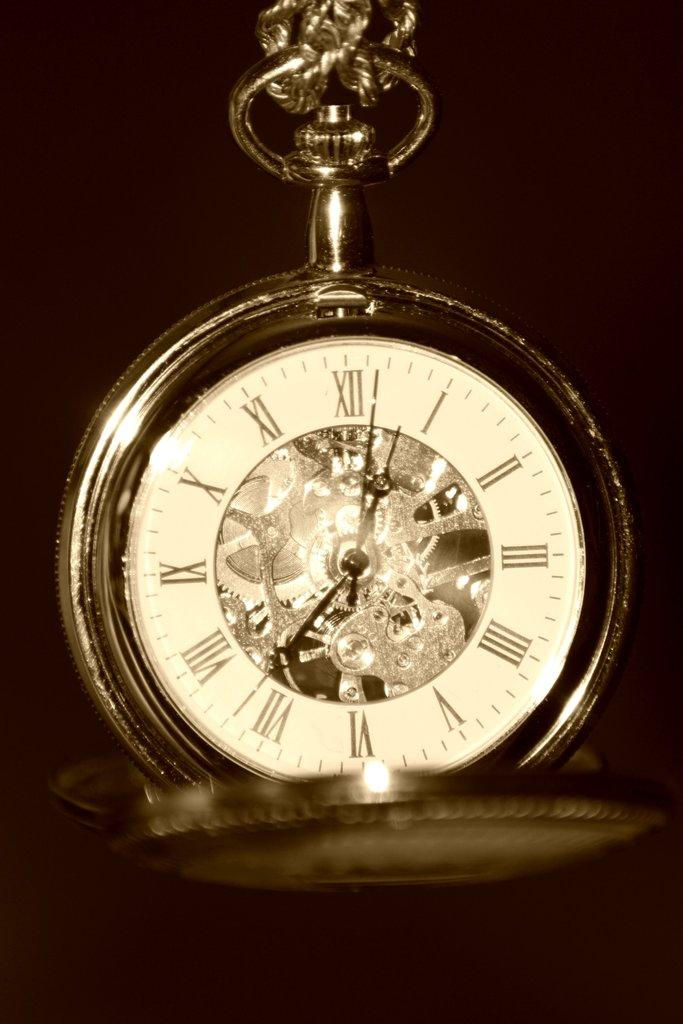<image>
Write a terse but informative summary of the picture. dark background and open pocket watch showing time of 12:27 